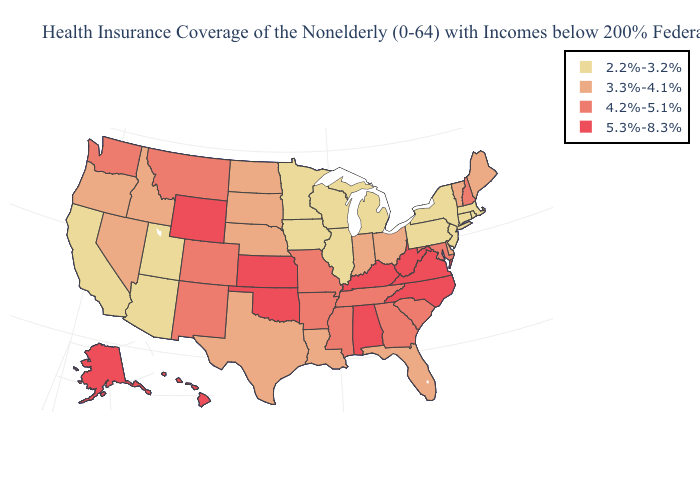What is the lowest value in states that border Maine?
Give a very brief answer. 4.2%-5.1%. What is the value of Illinois?
Short answer required. 2.2%-3.2%. Does Florida have a higher value than West Virginia?
Answer briefly. No. Name the states that have a value in the range 5.3%-8.3%?
Keep it brief. Alabama, Alaska, Hawaii, Kansas, Kentucky, North Carolina, Oklahoma, Virginia, West Virginia, Wyoming. Name the states that have a value in the range 4.2%-5.1%?
Concise answer only. Arkansas, Colorado, Georgia, Maryland, Mississippi, Missouri, Montana, New Hampshire, New Mexico, South Carolina, Tennessee, Washington. Name the states that have a value in the range 2.2%-3.2%?
Quick response, please. Arizona, California, Connecticut, Illinois, Iowa, Massachusetts, Michigan, Minnesota, New Jersey, New York, Pennsylvania, Rhode Island, Utah, Wisconsin. What is the lowest value in the USA?
Give a very brief answer. 2.2%-3.2%. What is the value of Minnesota?
Be succinct. 2.2%-3.2%. Among the states that border Michigan , does Indiana have the lowest value?
Be succinct. No. What is the lowest value in states that border Idaho?
Give a very brief answer. 2.2%-3.2%. What is the lowest value in the USA?
Be succinct. 2.2%-3.2%. What is the lowest value in states that border North Carolina?
Keep it brief. 4.2%-5.1%. Name the states that have a value in the range 4.2%-5.1%?
Answer briefly. Arkansas, Colorado, Georgia, Maryland, Mississippi, Missouri, Montana, New Hampshire, New Mexico, South Carolina, Tennessee, Washington. What is the value of New Hampshire?
Write a very short answer. 4.2%-5.1%. 